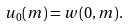Convert formula to latex. <formula><loc_0><loc_0><loc_500><loc_500>u _ { 0 } ( m ) = w ( 0 , m ) .</formula> 